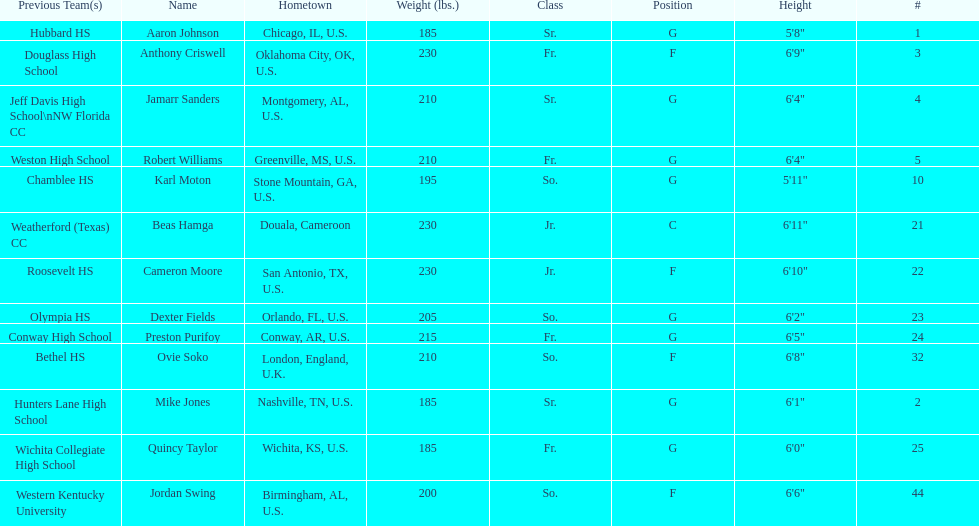Other than soko, who are the players? Aaron Johnson, Anthony Criswell, Jamarr Sanders, Robert Williams, Karl Moton, Beas Hamga, Cameron Moore, Dexter Fields, Preston Purifoy, Mike Jones, Quincy Taylor, Jordan Swing. Of those players, who is a player that is not from the us? Beas Hamga. 